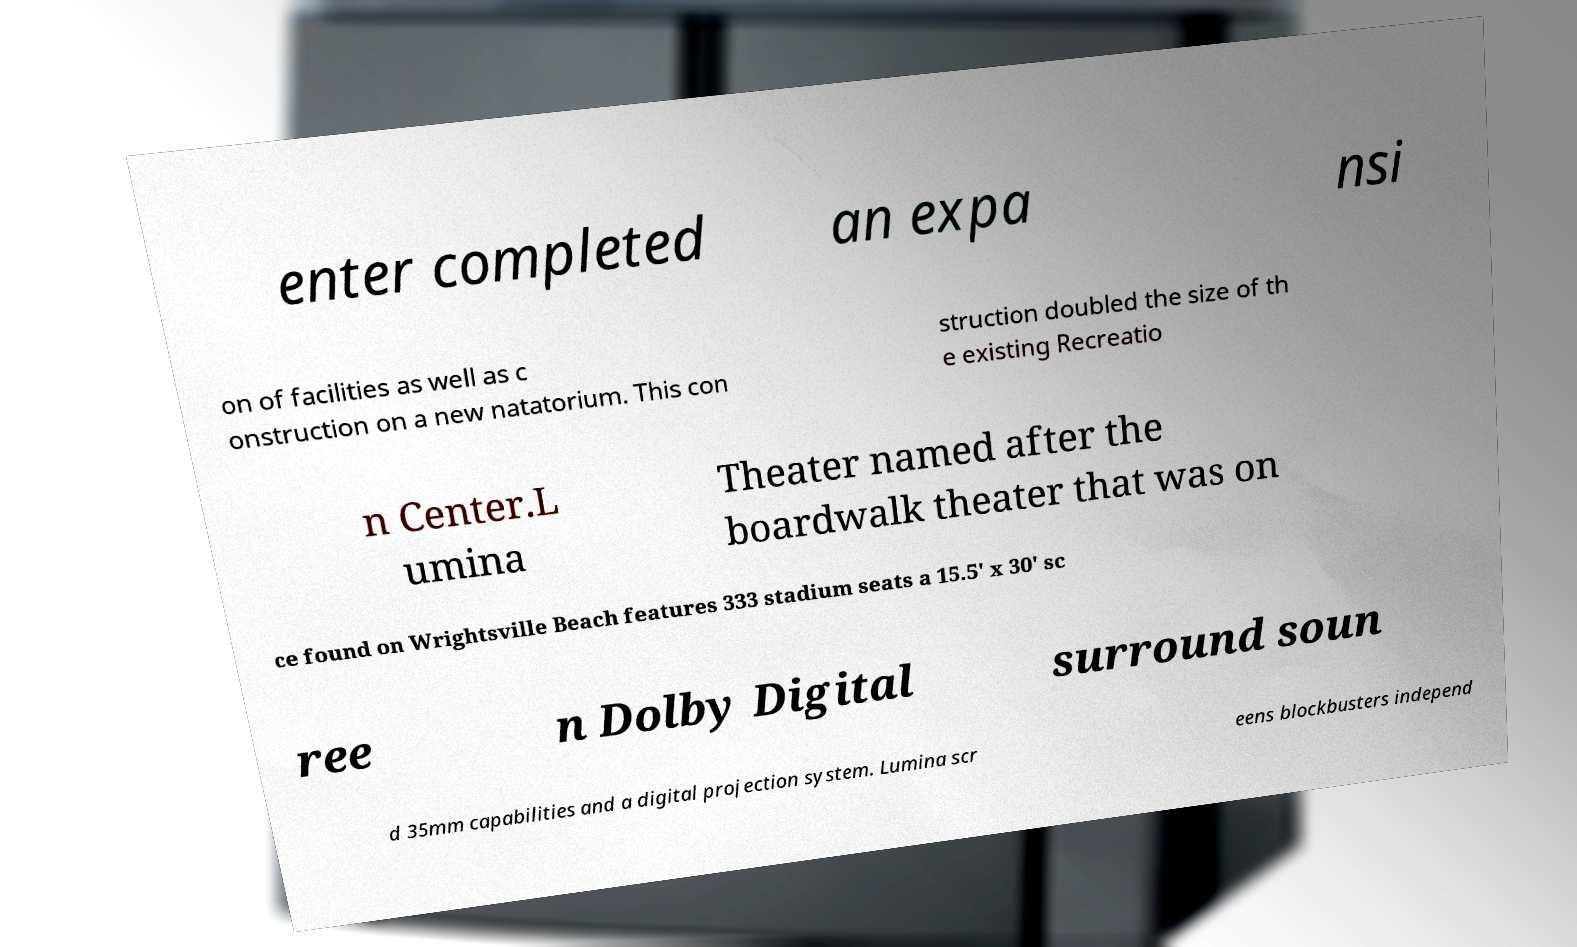Please read and relay the text visible in this image. What does it say? enter completed an expa nsi on of facilities as well as c onstruction on a new natatorium. This con struction doubled the size of th e existing Recreatio n Center.L umina Theater named after the boardwalk theater that was on ce found on Wrightsville Beach features 333 stadium seats a 15.5' x 30' sc ree n Dolby Digital surround soun d 35mm capabilities and a digital projection system. Lumina scr eens blockbusters independ 